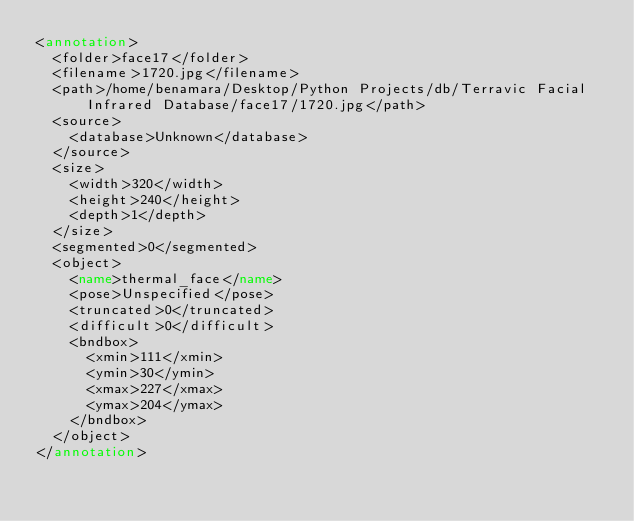<code> <loc_0><loc_0><loc_500><loc_500><_XML_><annotation>
	<folder>face17</folder>
	<filename>1720.jpg</filename>
	<path>/home/benamara/Desktop/Python Projects/db/Terravic Facial Infrared Database/face17/1720.jpg</path>
	<source>
		<database>Unknown</database>
	</source>
	<size>
		<width>320</width>
		<height>240</height>
		<depth>1</depth>
	</size>
	<segmented>0</segmented>
	<object>
		<name>thermal_face</name>
		<pose>Unspecified</pose>
		<truncated>0</truncated>
		<difficult>0</difficult>
		<bndbox>
			<xmin>111</xmin>
			<ymin>30</ymin>
			<xmax>227</xmax>
			<ymax>204</ymax>
		</bndbox>
	</object>
</annotation>
</code> 